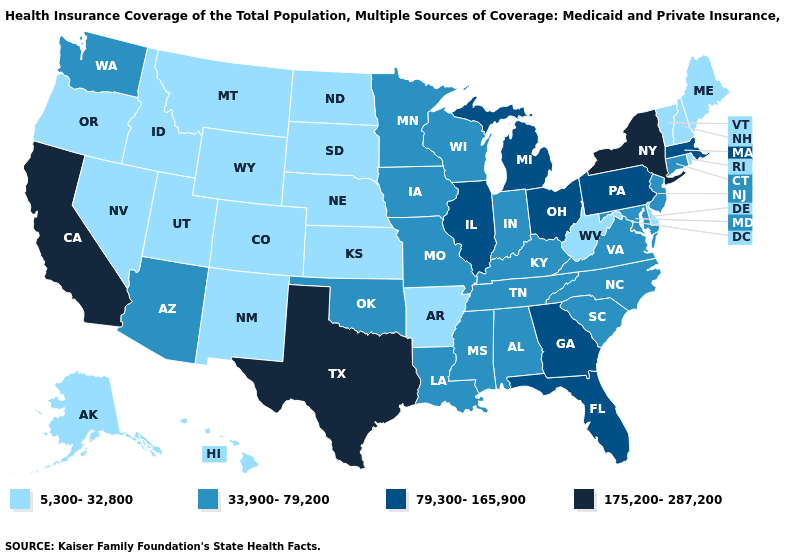What is the highest value in states that border Nebraska?
Be succinct. 33,900-79,200. What is the highest value in the South ?
Answer briefly. 175,200-287,200. What is the value of Oregon?
Concise answer only. 5,300-32,800. What is the value of Maryland?
Answer briefly. 33,900-79,200. What is the lowest value in the USA?
Be succinct. 5,300-32,800. What is the value of Florida?
Keep it brief. 79,300-165,900. Does the map have missing data?
Give a very brief answer. No. What is the value of Florida?
Answer briefly. 79,300-165,900. Does New York have the same value as California?
Write a very short answer. Yes. Name the states that have a value in the range 5,300-32,800?
Keep it brief. Alaska, Arkansas, Colorado, Delaware, Hawaii, Idaho, Kansas, Maine, Montana, Nebraska, Nevada, New Hampshire, New Mexico, North Dakota, Oregon, Rhode Island, South Dakota, Utah, Vermont, West Virginia, Wyoming. Name the states that have a value in the range 33,900-79,200?
Give a very brief answer. Alabama, Arizona, Connecticut, Indiana, Iowa, Kentucky, Louisiana, Maryland, Minnesota, Mississippi, Missouri, New Jersey, North Carolina, Oklahoma, South Carolina, Tennessee, Virginia, Washington, Wisconsin. What is the highest value in the USA?
Write a very short answer. 175,200-287,200. Does Texas have the highest value in the USA?
Be succinct. Yes. Does Ohio have the lowest value in the MidWest?
Short answer required. No. What is the value of Tennessee?
Answer briefly. 33,900-79,200. 